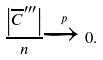Convert formula to latex. <formula><loc_0><loc_0><loc_500><loc_500>\frac { \left | \overline { C } ^ { \prime \prime \prime } \right | } { n } \xrightarrow { p } 0 .</formula> 